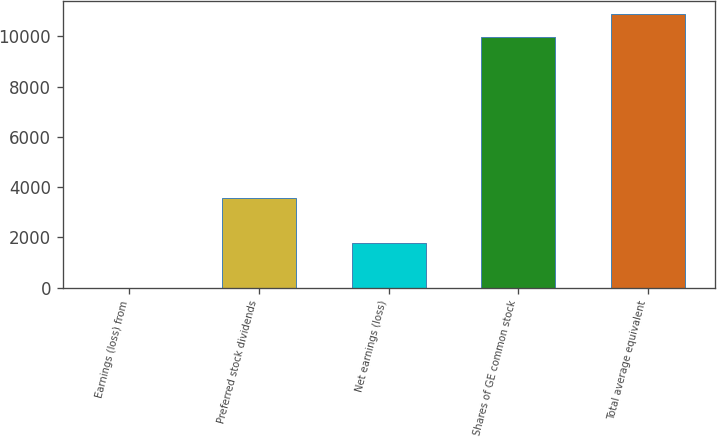Convert chart. <chart><loc_0><loc_0><loc_500><loc_500><bar_chart><fcel>Earnings (loss) from<fcel>Preferred stock dividends<fcel>Net earnings (loss)<fcel>Shares of GE common stock<fcel>Total average equivalent<nl><fcel>0.04<fcel>3577.64<fcel>1788.84<fcel>9981.8<fcel>10876.2<nl></chart> 